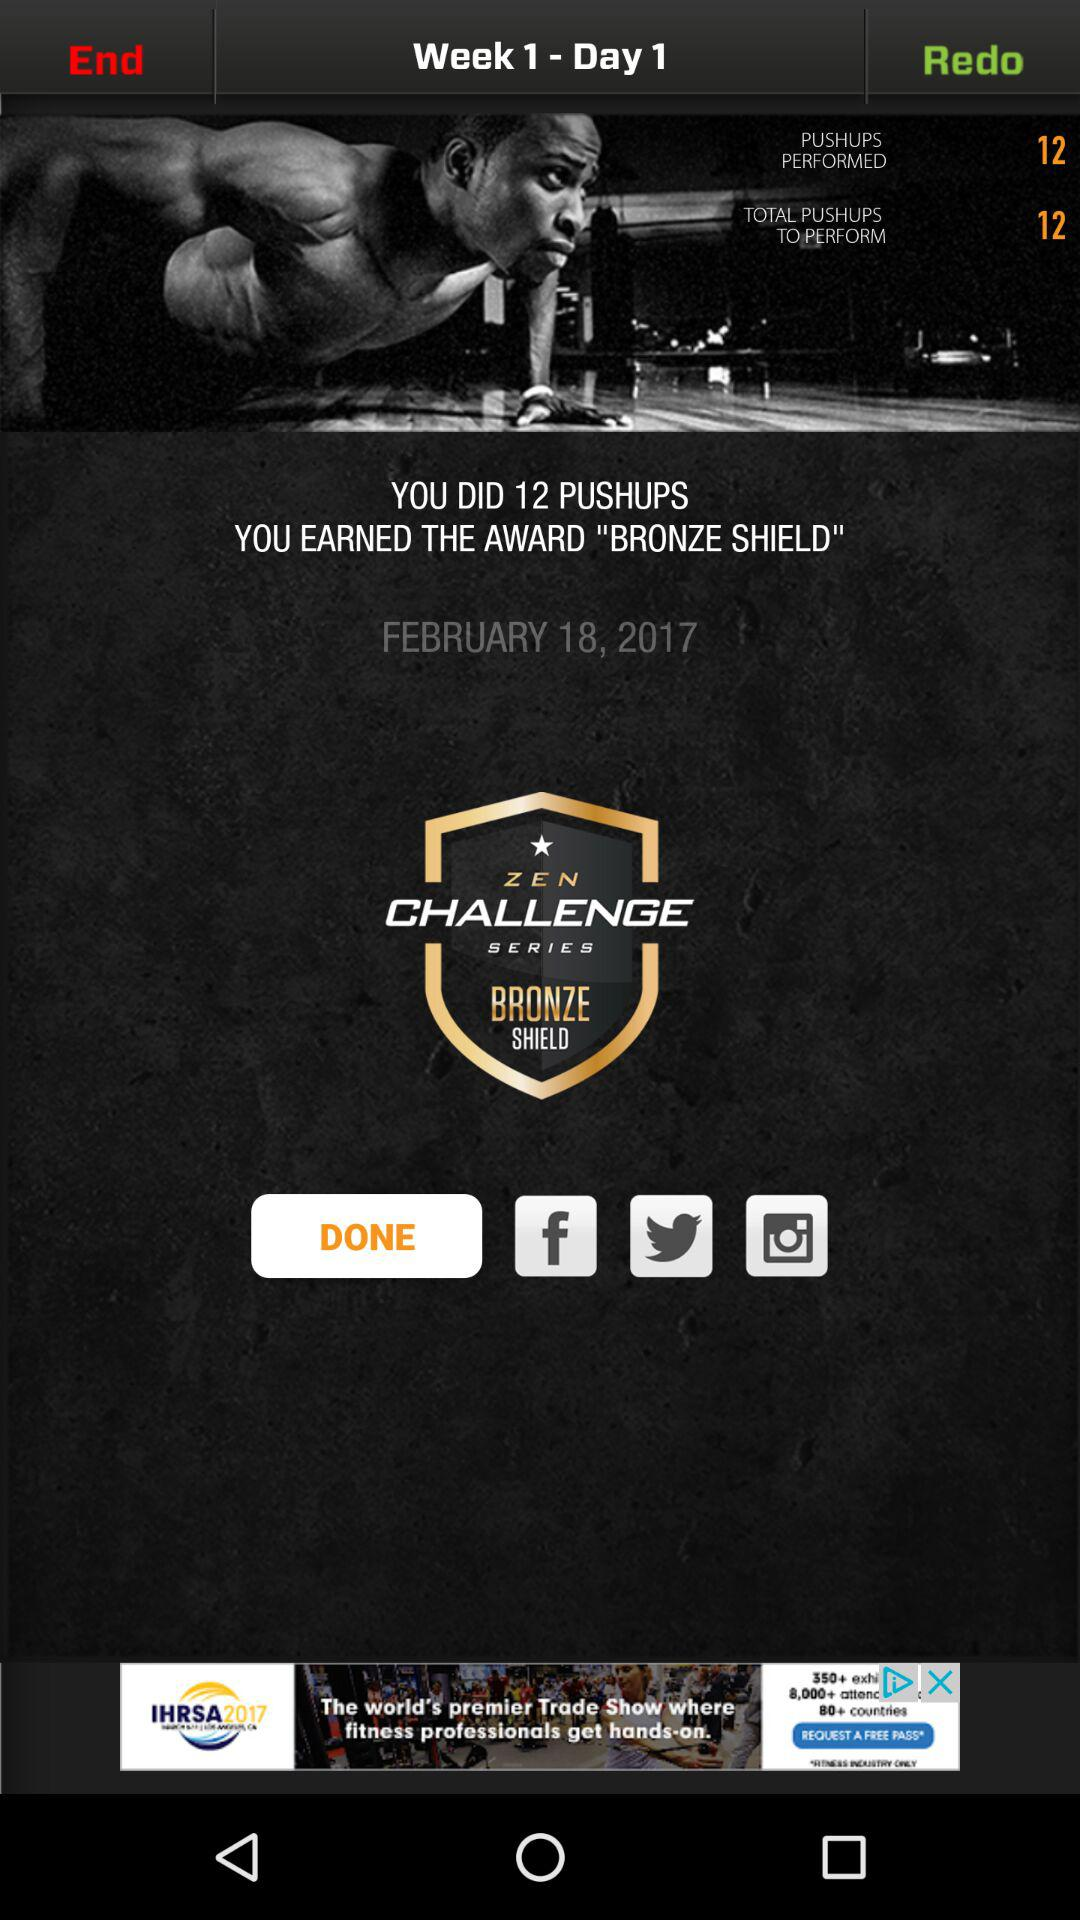What is the date of the workout?
Answer the question using a single word or phrase. February 18, 2017 